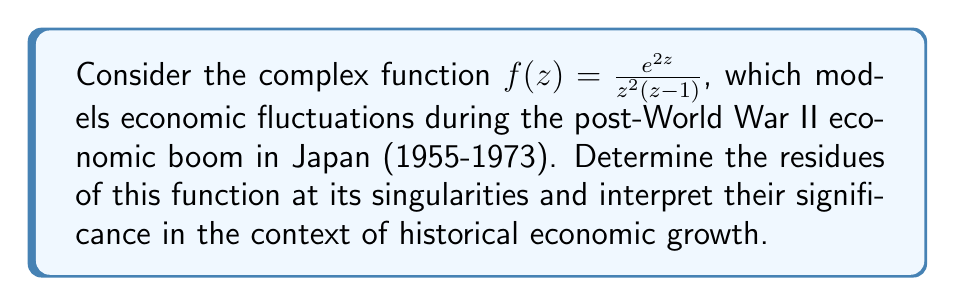What is the answer to this math problem? To solve this problem, we'll follow these steps:

1) Identify the singularities of the function.
2) Determine the order of each singularity.
3) Calculate the residues using the appropriate method for each singularity.
4) Interpret the results in the context of historical economic growth.

Step 1: Identifying the singularities
The singularities of $f(z)$ occur where the denominator is zero:
- $z = 0$ (order 2)
- $z = 1$ (order 1)

Step 2: Determining the order of each singularity
- At $z = 0$, we have a pole of order 2.
- At $z = 1$, we have a simple pole (order 1).

Step 3: Calculating the residues

For $z = 0$ (pole of order 2):
We use the formula for the residue of a pole of order 2:
$$ \text{Res}(f, 0) = \lim_{z \to 0} \frac{d}{dz} [z^2 f(z)] $$

$$ \begin{align*}
\text{Res}(f, 0) &= \lim_{z \to 0} \frac{d}{dz} [z^2 \cdot \frac{e^{2z}}{z^2(z-1)}] \\
&= \lim_{z \to 0} \frac{d}{dz} [\frac{e^{2z}}{z-1}] \\
&= \lim_{z \to 0} [\frac{2e^{2z}(z-1) - e^{2z}}{(z-1)^2}] \\
&= \frac{-e^0}{(-1)^2} = -1
\end{align*} $$

For $z = 1$ (simple pole):
We use the formula for the residue of a simple pole:
$$ \text{Res}(f, 1) = \lim_{z \to 1} (z-1) f(z) $$

$$ \begin{align*}
\text{Res}(f, 1) &= \lim_{z \to 1} (z-1) \cdot \frac{e^{2z}}{z^2(z-1)} \\
&= \lim_{z \to 1} \frac{e^{2z}}{z^2} \\
&= \frac{e^2}{1^2} = e^2
\end{align*} $$

Step 4: Interpretation
The residue at $z = 0$ is $-1$, which could represent a stabilizing force in the economy, possibly reflecting the efforts of post-war reconstruction policies.

The residue at $z = 1$ is $e^2 \approx 7.389$, a larger positive value. This could indicate a strong positive economic trend, aligning with the rapid economic growth Japan experienced during this period, often referred to as the "Japanese economic miracle".

These residues provide a mathematical representation of the economic dynamics during this historically significant period of growth in post-war Japan.
Answer: The residues of $f(z) = \frac{e^{2z}}{z^2(z-1)}$ are:
$\text{Res}(f, 0) = -1$
$\text{Res}(f, 1) = e^2$ 